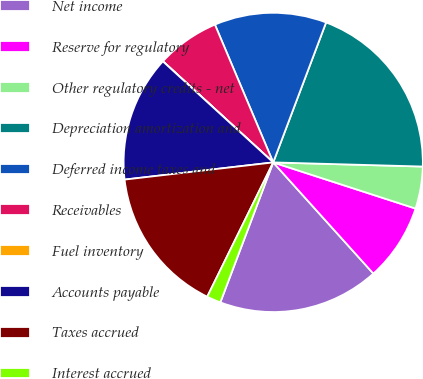<chart> <loc_0><loc_0><loc_500><loc_500><pie_chart><fcel>Net income<fcel>Reserve for regulatory<fcel>Other regulatory credits - net<fcel>Depreciation amortization and<fcel>Deferred income taxes and<fcel>Receivables<fcel>Fuel inventory<fcel>Accounts payable<fcel>Taxes accrued<fcel>Interest accrued<nl><fcel>17.42%<fcel>8.34%<fcel>4.55%<fcel>19.69%<fcel>12.12%<fcel>6.82%<fcel>0.01%<fcel>13.63%<fcel>15.9%<fcel>1.52%<nl></chart> 